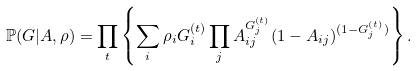<formula> <loc_0><loc_0><loc_500><loc_500>\mathbb { P } ( G | A , \rho ) = \prod _ { t } \left \{ \sum _ { i } \rho _ { i } G _ { i } ^ { ( t ) } \prod _ { j } A _ { i j } ^ { G _ { j } ^ { ( t ) } } ( 1 - A _ { i j } ) ^ { ( 1 - G _ { j } ^ { ( t ) } ) } \right \} .</formula> 